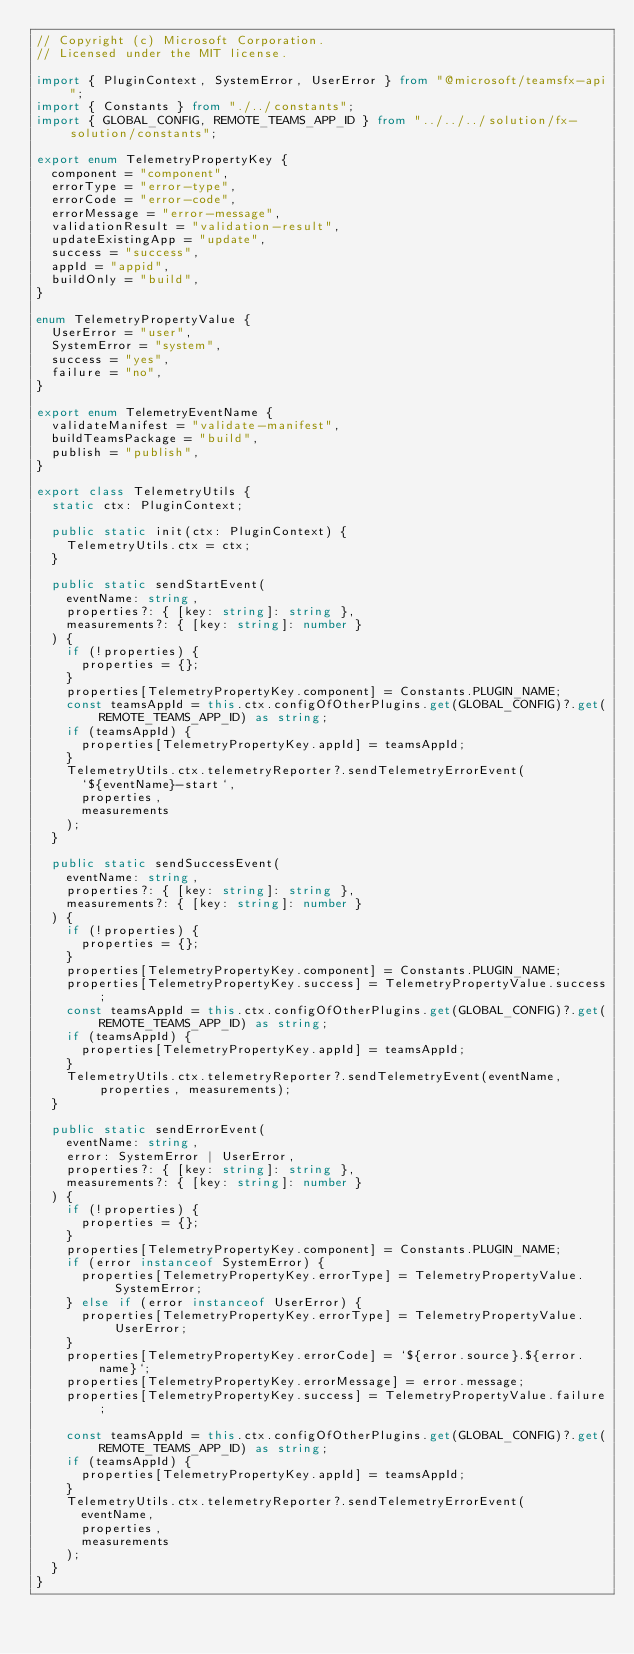Convert code to text. <code><loc_0><loc_0><loc_500><loc_500><_TypeScript_>// Copyright (c) Microsoft Corporation.
// Licensed under the MIT license.

import { PluginContext, SystemError, UserError } from "@microsoft/teamsfx-api";
import { Constants } from "./../constants";
import { GLOBAL_CONFIG, REMOTE_TEAMS_APP_ID } from "../../../solution/fx-solution/constants";

export enum TelemetryPropertyKey {
  component = "component",
  errorType = "error-type",
  errorCode = "error-code",
  errorMessage = "error-message",
  validationResult = "validation-result",
  updateExistingApp = "update",
  success = "success",
  appId = "appid",
  buildOnly = "build",
}

enum TelemetryPropertyValue {
  UserError = "user",
  SystemError = "system",
  success = "yes",
  failure = "no",
}

export enum TelemetryEventName {
  validateManifest = "validate-manifest",
  buildTeamsPackage = "build",
  publish = "publish",
}

export class TelemetryUtils {
  static ctx: PluginContext;

  public static init(ctx: PluginContext) {
    TelemetryUtils.ctx = ctx;
  }

  public static sendStartEvent(
    eventName: string,
    properties?: { [key: string]: string },
    measurements?: { [key: string]: number }
  ) {
    if (!properties) {
      properties = {};
    }
    properties[TelemetryPropertyKey.component] = Constants.PLUGIN_NAME;
    const teamsAppId = this.ctx.configOfOtherPlugins.get(GLOBAL_CONFIG)?.get(REMOTE_TEAMS_APP_ID) as string;
    if (teamsAppId) {
      properties[TelemetryPropertyKey.appId] = teamsAppId;
    }
    TelemetryUtils.ctx.telemetryReporter?.sendTelemetryErrorEvent(
      `${eventName}-start`,
      properties,
      measurements
    );
  }

  public static sendSuccessEvent(
    eventName: string,
    properties?: { [key: string]: string },
    measurements?: { [key: string]: number }
  ) {
    if (!properties) {
      properties = {};
    }
    properties[TelemetryPropertyKey.component] = Constants.PLUGIN_NAME;
    properties[TelemetryPropertyKey.success] = TelemetryPropertyValue.success;
    const teamsAppId = this.ctx.configOfOtherPlugins.get(GLOBAL_CONFIG)?.get(REMOTE_TEAMS_APP_ID) as string;
    if (teamsAppId) {
      properties[TelemetryPropertyKey.appId] = teamsAppId;
    }
    TelemetryUtils.ctx.telemetryReporter?.sendTelemetryEvent(eventName, properties, measurements);
  }

  public static sendErrorEvent(
    eventName: string,
    error: SystemError | UserError,
    properties?: { [key: string]: string },
    measurements?: { [key: string]: number }
  ) {
    if (!properties) {
      properties = {};
    }
    properties[TelemetryPropertyKey.component] = Constants.PLUGIN_NAME;
    if (error instanceof SystemError) {
      properties[TelemetryPropertyKey.errorType] = TelemetryPropertyValue.SystemError;
    } else if (error instanceof UserError) {
      properties[TelemetryPropertyKey.errorType] = TelemetryPropertyValue.UserError;
    }
    properties[TelemetryPropertyKey.errorCode] = `${error.source}.${error.name}`;
    properties[TelemetryPropertyKey.errorMessage] = error.message;
    properties[TelemetryPropertyKey.success] = TelemetryPropertyValue.failure;

    const teamsAppId = this.ctx.configOfOtherPlugins.get(GLOBAL_CONFIG)?.get(REMOTE_TEAMS_APP_ID) as string;
    if (teamsAppId) {
      properties[TelemetryPropertyKey.appId] = teamsAppId;
    }
    TelemetryUtils.ctx.telemetryReporter?.sendTelemetryErrorEvent(
      eventName,
      properties,
      measurements
    );
  }
}
</code> 